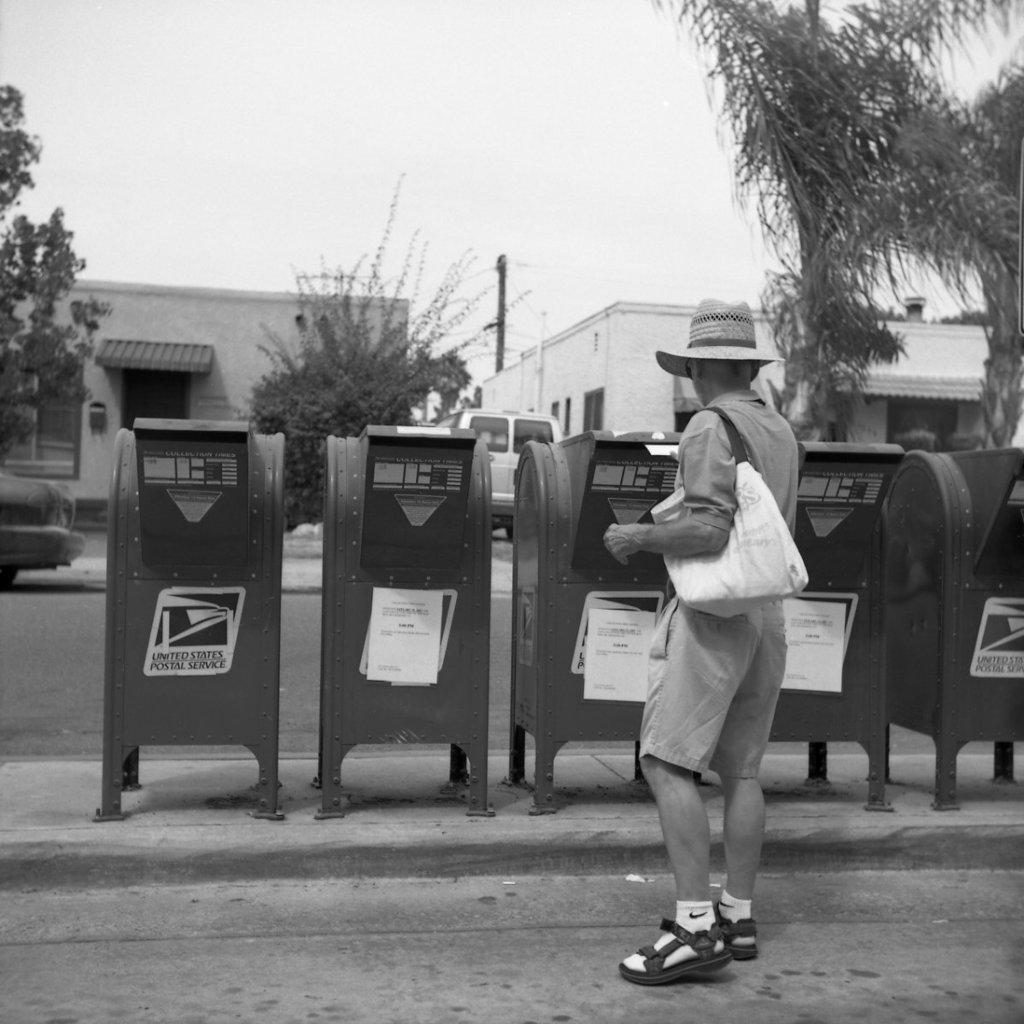What is the name of the postal service?
Provide a succinct answer. United states postal service. 